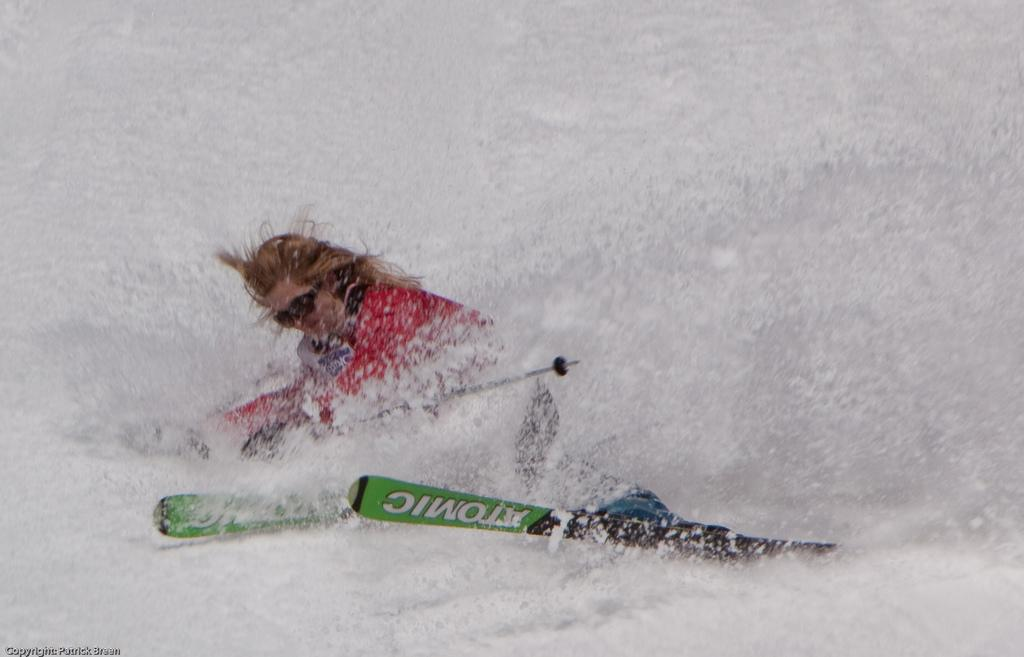Who is present in the image? There is a person in the image. What is the person doing in the image? The person is skiing. On what surface is the person skiing? The person is skiing on the snow. What type of lace can be seen on the person's shoes while skiing? There is no mention of lace or shoes in the image, as the person is wearing ski boots. 